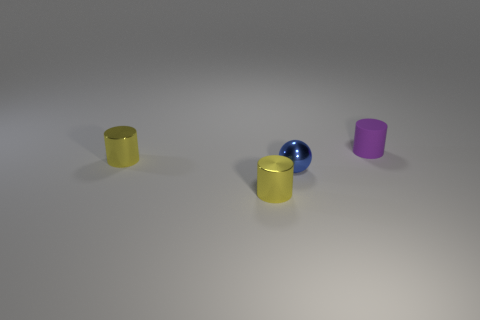Is there any other thing that is the same material as the tiny purple object?
Provide a succinct answer. No. What is the shape of the small purple matte object that is right of the small blue thing?
Your response must be concise. Cylinder. There is a tiny yellow metallic object on the left side of the yellow shiny thing that is in front of the small blue shiny thing; how many tiny yellow metallic objects are left of it?
Make the answer very short. 0. Are there the same number of tiny yellow metallic objects that are to the right of the tiny rubber object and big rubber balls?
Provide a short and direct response. Yes. How many blocks are tiny matte objects or small blue shiny things?
Make the answer very short. 0. Is the ball the same color as the tiny rubber object?
Your answer should be compact. No. Are there an equal number of blue things on the left side of the sphere and purple cylinders right of the purple rubber thing?
Your response must be concise. Yes. The tiny rubber object is what color?
Keep it short and to the point. Purple. How many things are either things that are on the left side of the tiny rubber thing or large red things?
Give a very brief answer. 3. Does the object in front of the ball have the same size as the yellow cylinder behind the blue sphere?
Ensure brevity in your answer.  Yes. 